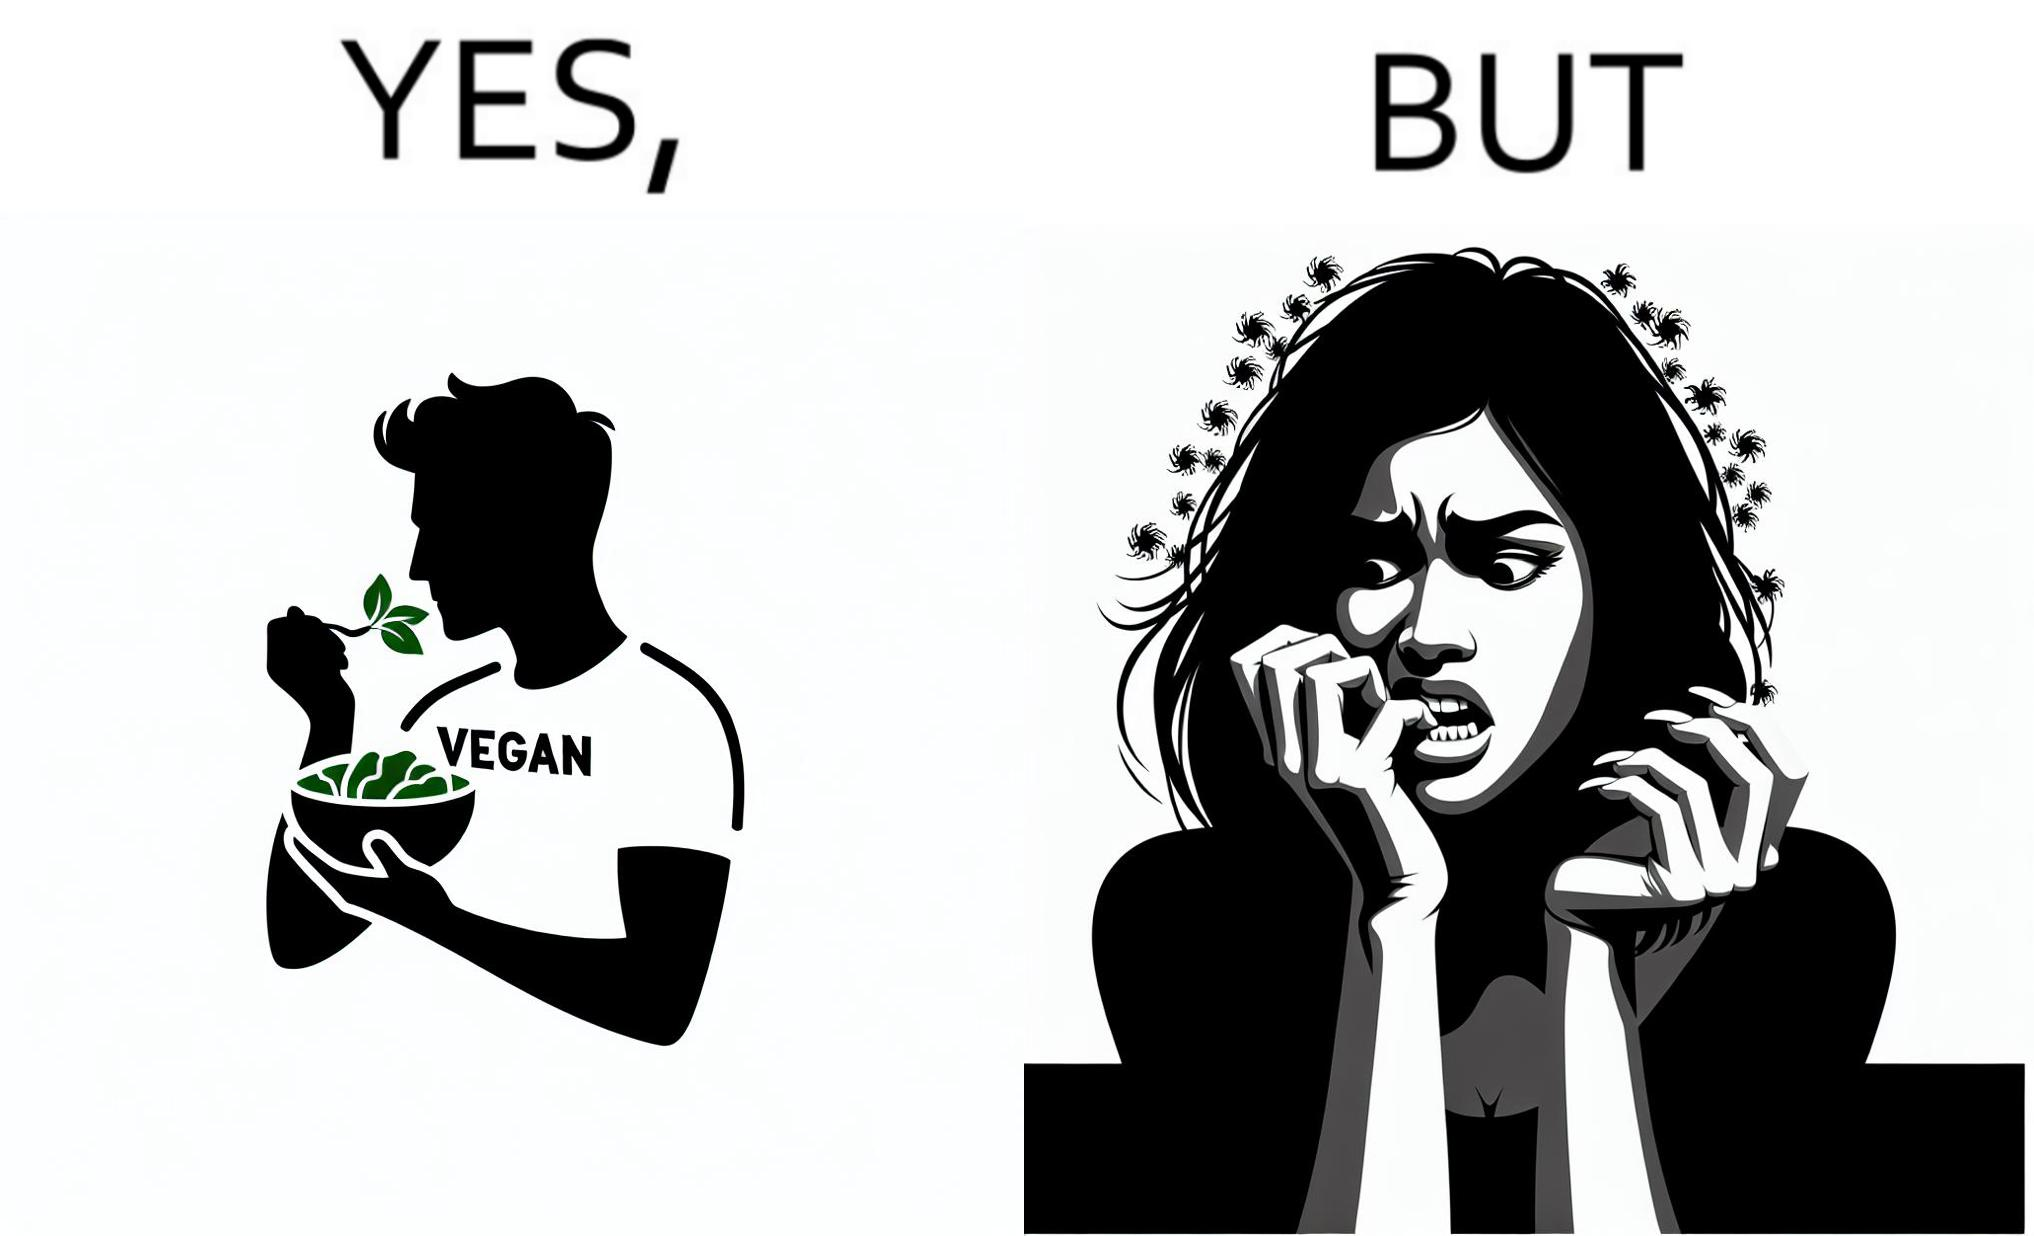Is this image satirical or non-satirical? Yes, this image is satirical. 